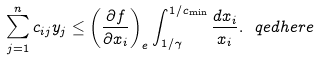<formula> <loc_0><loc_0><loc_500><loc_500>\sum _ { j = 1 } ^ { n } c _ { i j } y _ { j } \leq \left ( \frac { \partial f } { \partial x _ { i } } \right ) _ { e } \int _ { 1 / \gamma } ^ { 1 / c _ { \min } } \frac { d x _ { i } } { x _ { i } } . \ q e d h e r e</formula> 